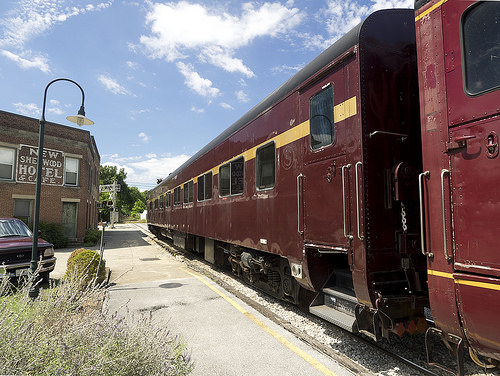<image>
Can you confirm if the train is in front of the track? No. The train is not in front of the track. The spatial positioning shows a different relationship between these objects. 